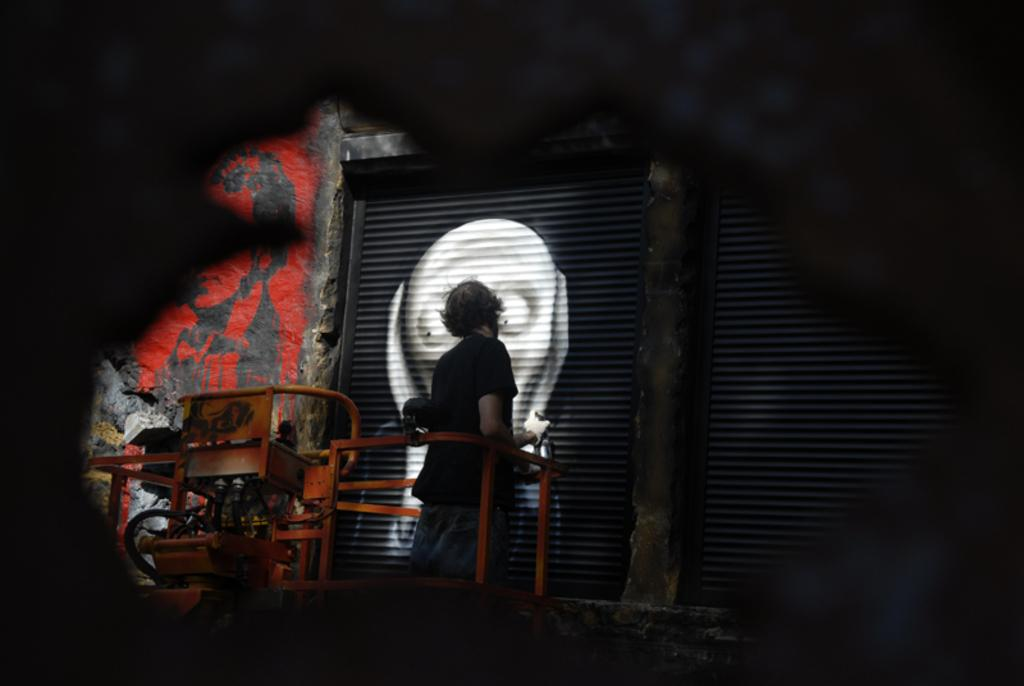What is the person in the image doing? The person is painting on a shutter. What is the person wearing in the image? The person is wearing a black T-shirt. What is the person standing on in the image? The person is standing on a lifter machine. What is the person holding in the image? The person is holding a paint bottle. What can be inferred about the lighting conditions in the image? The image is taken in a dark environment. What type of dinner is being served in the image? There is no dinner present in the image; it features a person painting on a shutter. What vegetable is being used as a paintbrush in the image? There is no vegetable being used as a paintbrush in the image; the person is holding a paint bottle. 